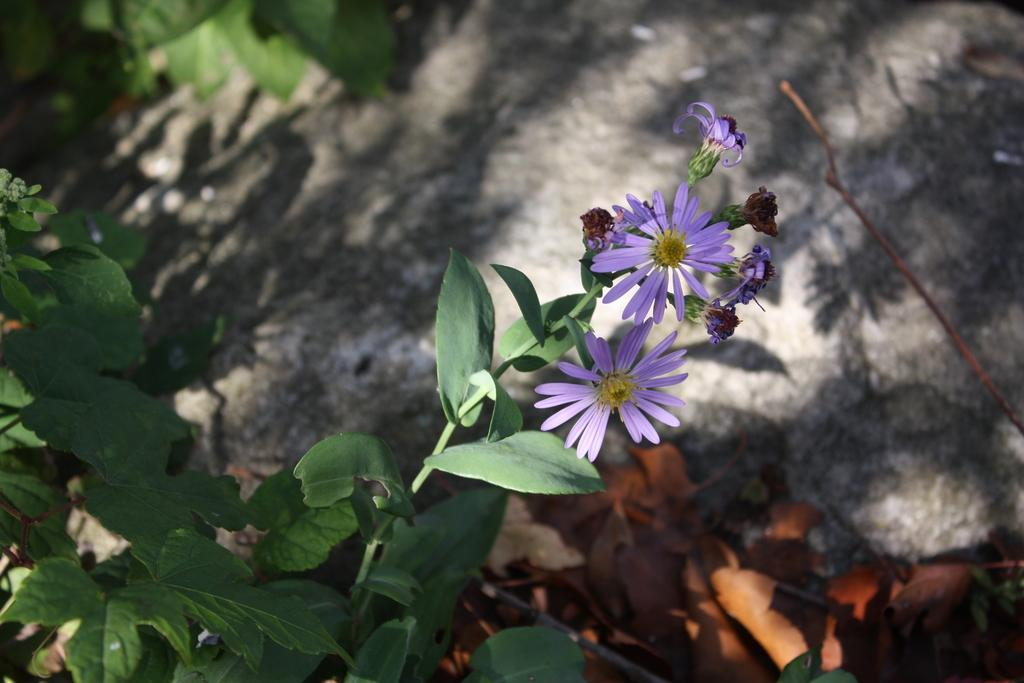What type of plant is visible in the image? There is a plant in the image, and it has leaves and flowers. What can be found behind the plant? There are dry leaves and a rock behind the plant. What causes the drain to burst in the image? There is no drain or bursting event present in the image; it features a plant with leaves and flowers, dry leaves, and a rock behind it. 